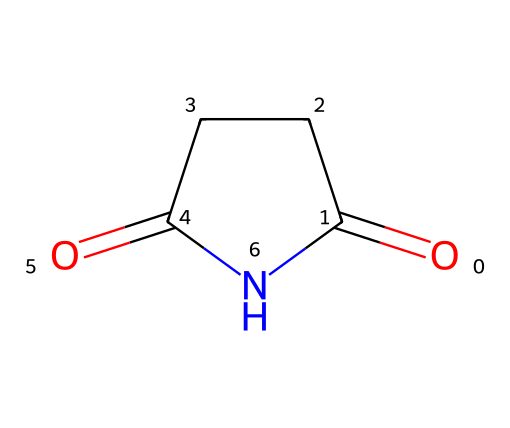What is the name of this chemical? The structure represented by the SMILES code is known as succinimide, which is indicated by the imide functional group and specific carbon and nitrogen arrangement.
Answer: succinimide How many carbon atoms are in succinimide? By analyzing the structure, we can count a total of 4 carbon atoms present in the cyclic part of the structure.
Answer: 4 How many nitrogen atoms are in this molecule? The structural representation shows one nitrogen atom within the imide functional group, making it easy to identify through the visual.
Answer: 1 What type of functional group is present in succinimide? The structure features a cyclic structure with a nitrogen atom bonded to carbonyl groups, defining it as an imide functional group specifically.
Answer: imide What is the molecular formula of succinimide? The molecular composition of succinimide can be derived from the structure, resulting in the formula C4H5NO2, which outlines the number of each type of atom present.
Answer: C4H5NO2 Why is succinimide used in skincare formulations? Succinimide is known for its moisturizing and skin-conditioning properties, making it a popular ingredient in many skincare products focused on hydration and improving skin texture.
Answer: moisturizing How does succinimide interact with skin? Succinimide functions to enhance moisture retention and skin softness, which is crucial in skincare formulations aimed at improving the overall texture and feel of the skin.
Answer: enhances moisture retention 